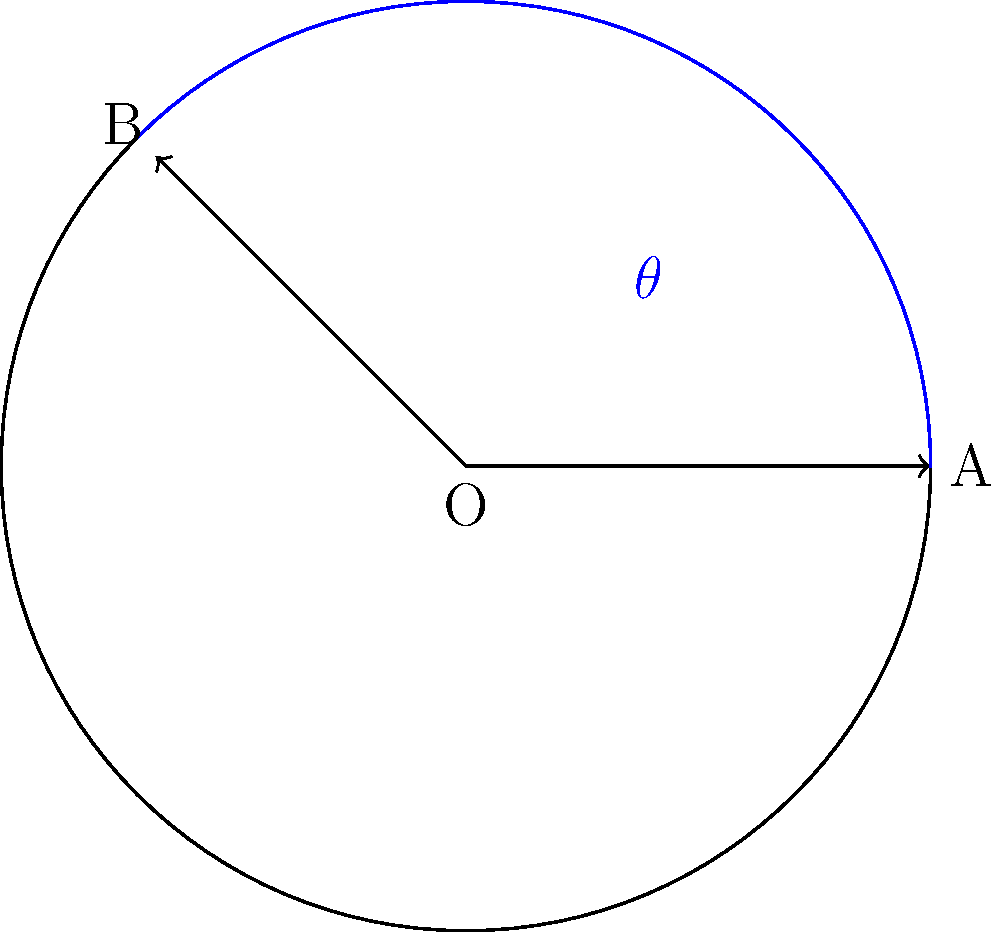Two fire truck ladders are extended from the same point on the ground to reach different windows of a burning building. The angle between the ladders is $\theta$. If one ladder makes an angle of 60° with the ground and the other makes an angle of 45° with the ground, what is the value of $\theta$? Let's approach this step-by-step:

1) First, we need to visualize the scenario. Imagine a circle with its center at the point where the ladders meet the ground. The ladders form radii of this circle.

2) The angle between a ladder and the ground is the same as the angle between that ladder and the horizontal radius of the circle.

3) We're given that one ladder makes a 60° angle with the ground, and the other makes a 45° angle with the ground.

4) The angle we're looking for, $\theta$, is the angle between these two ladders.

5) In a circle, the angle between any two radii is equal to the difference of the angles they make with the horizontal radius if they're on the same side of the horizontal, or the sum if they're on opposite sides.

6) In this case, the ladders are on the same side of the horizontal (both above it), so we subtract the smaller angle from the larger:

   $\theta = 60° - 45° = 15°$

Therefore, the angle between the two ladders is 15°.
Answer: 15° 